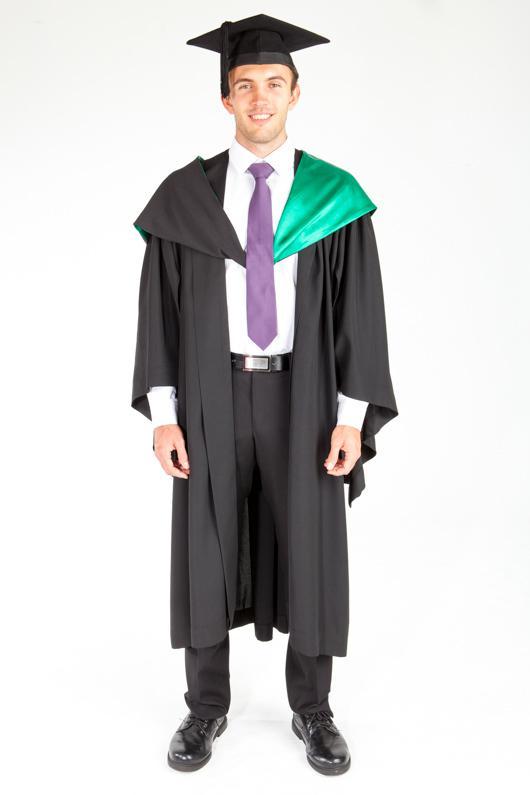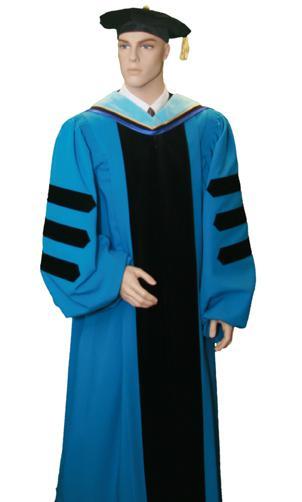The first image is the image on the left, the second image is the image on the right. Analyze the images presented: Is the assertion "An image shows a mannequin wearing a graduation robe with black stripes on its sleeves." valid? Answer yes or no. Yes. The first image is the image on the left, the second image is the image on the right. Assess this claim about the two images: "All graduation gowns and caps with tassles are modeled by real people, but only person is shown full length from head to foot.". Correct or not? Answer yes or no. No. 